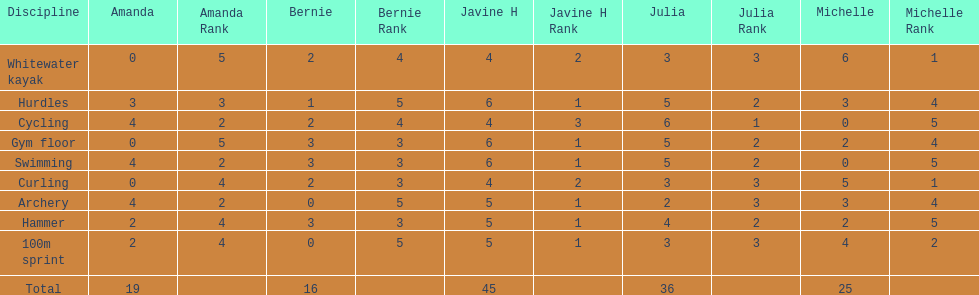Who scored the least on whitewater kayak? Amanda. 